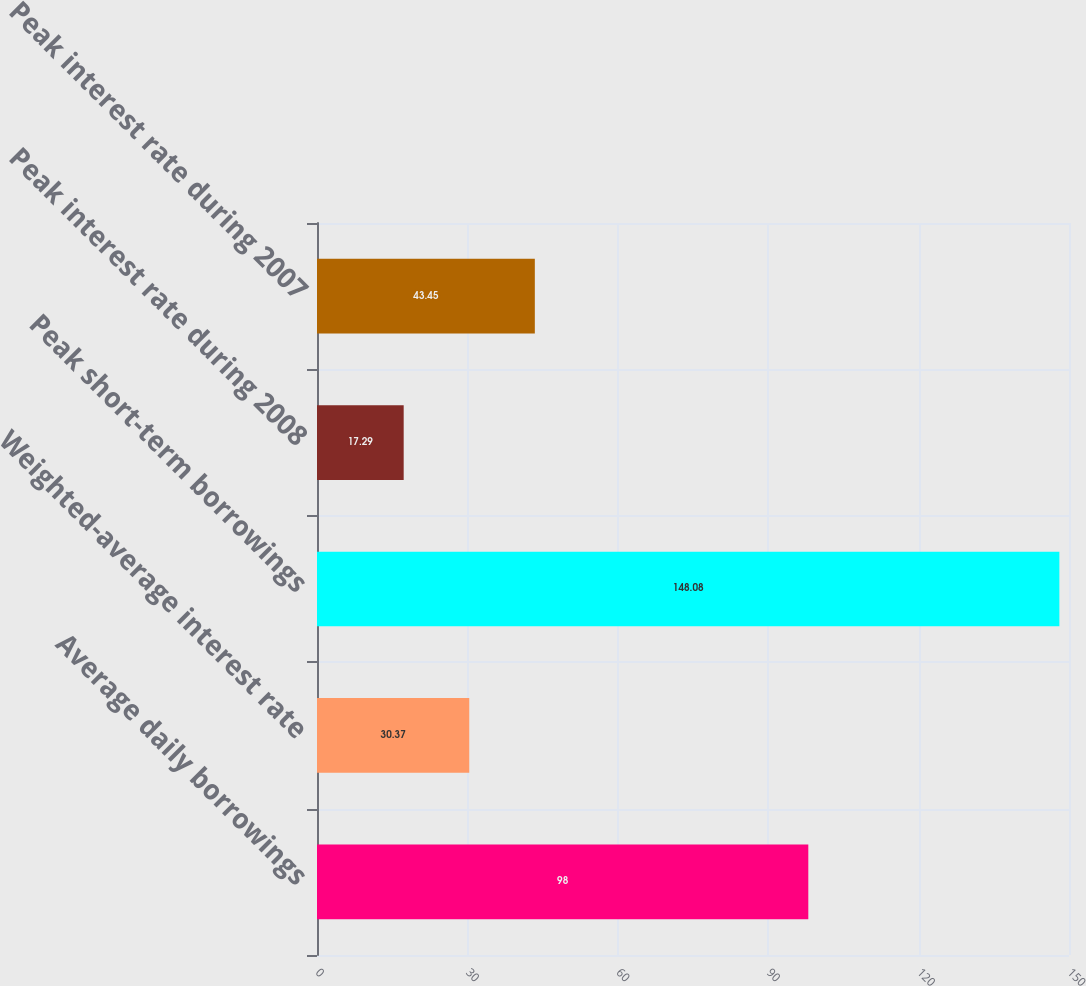<chart> <loc_0><loc_0><loc_500><loc_500><bar_chart><fcel>Average daily borrowings<fcel>Weighted-average interest rate<fcel>Peak short-term borrowings<fcel>Peak interest rate during 2008<fcel>Peak interest rate during 2007<nl><fcel>98<fcel>30.37<fcel>148.08<fcel>17.29<fcel>43.45<nl></chart> 